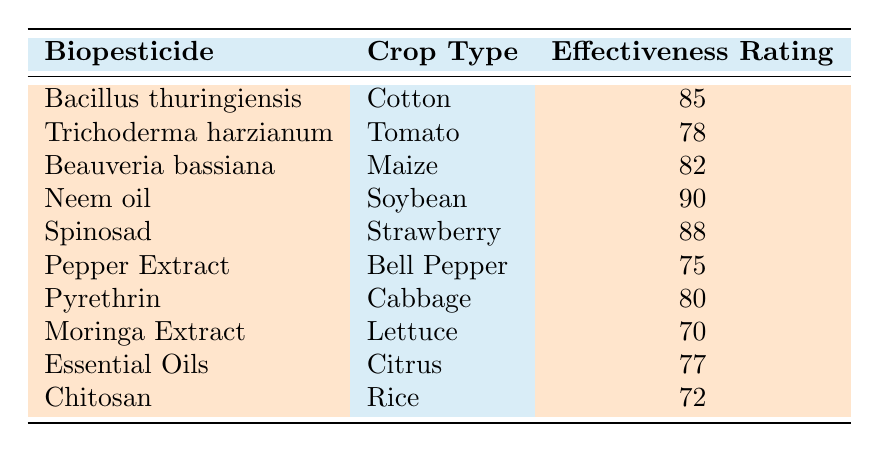What is the effectiveness rating of Neem oil? Neem oil is listed in the table with an effectiveness rating of 90, which is shown in the third column of its respective row.
Answer: 90 Which biopesticide has the lowest effectiveness rating? By comparing all the effectiveness ratings listed in the table, Moringa Extract has the lowest rating at 70.
Answer: Moringa Extract What is the average effectiveness rating of the biopesticides listed? To find the average, add all the effectiveness ratings: (85 + 78 + 82 + 90 + 88 + 75 + 80 + 70 + 77 + 72) = 817. There are 10 biopesticides, then the average is 817/10 = 81.7.
Answer: 81.7 Is the effectiveness rating of Spinosad greater than that of Pyrethrin? Spinosad has an effectiveness rating of 88, while Pyrethrin has a rating of 80. Since 88 is greater than 80, the statement is true.
Answer: Yes How many biopesticides have an effectiveness rating above 80? By examining the table, the biopesticides with ratings above 80 are: Bacillus thuringiensis (85), Neem oil (90), Spinosad (88), and Beauveria bassiana (82), totaling 4.
Answer: 4 Which crop type has the highest effectiveness rating biopesticide? Neem oil, associated with Soybean, has the highest effectiveness rating of 90, making it the standout in the table.
Answer: Soybean What is the difference in effectiveness rating between the highest and lowest biopesticide ratings? The highest rating is 90 (Neem oil) and the lowest is 70 (Moringa Extract). The difference is 90 - 70 = 20.
Answer: 20 Are there any biopesticides with effectiveness ratings below 75? The table shows that Moringa Extract (70) and Pepper Extract (75) have ratings below 75. Therefore, there are biopesticides with ratings below 75.
Answer: Yes 